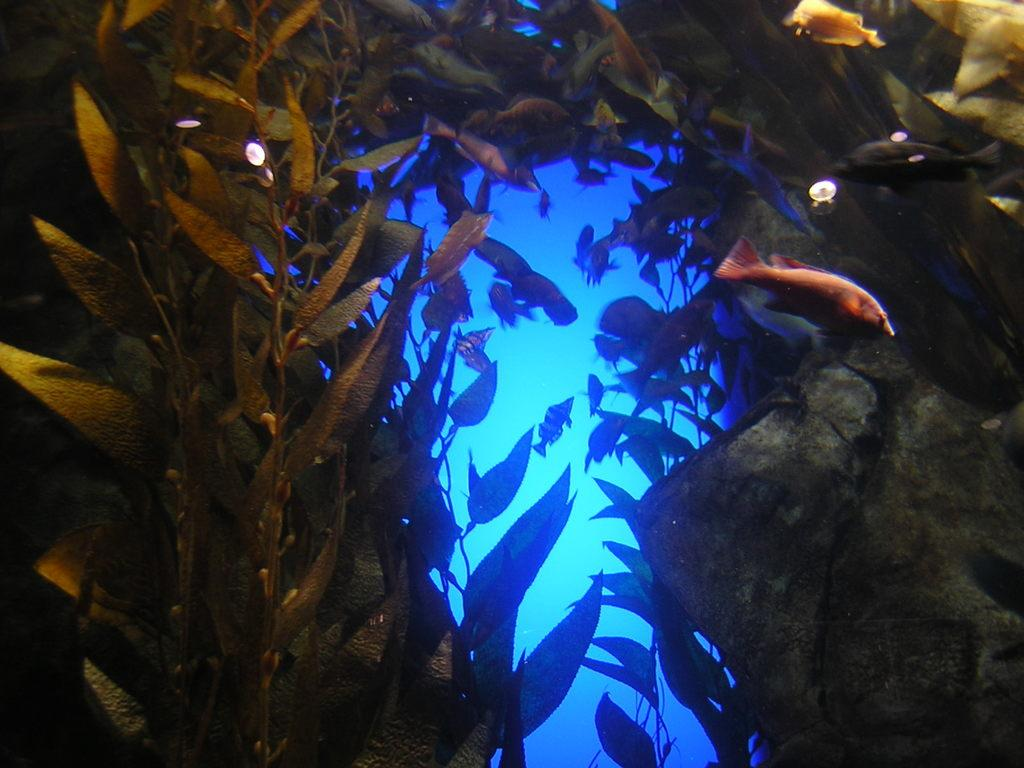What type of animals can be seen in the image? There are fishes in the image. What other living organisms are present in the image? There are plants in the image. Where are the fishes and plants located? The plants and fishes are in the water. Can you describe any other objects or features in the image? There appears to be a rock on the right side of the image. What is the weight of the car in the image? There is no car present in the image; it features fishes, plants, and a rock in the water. 